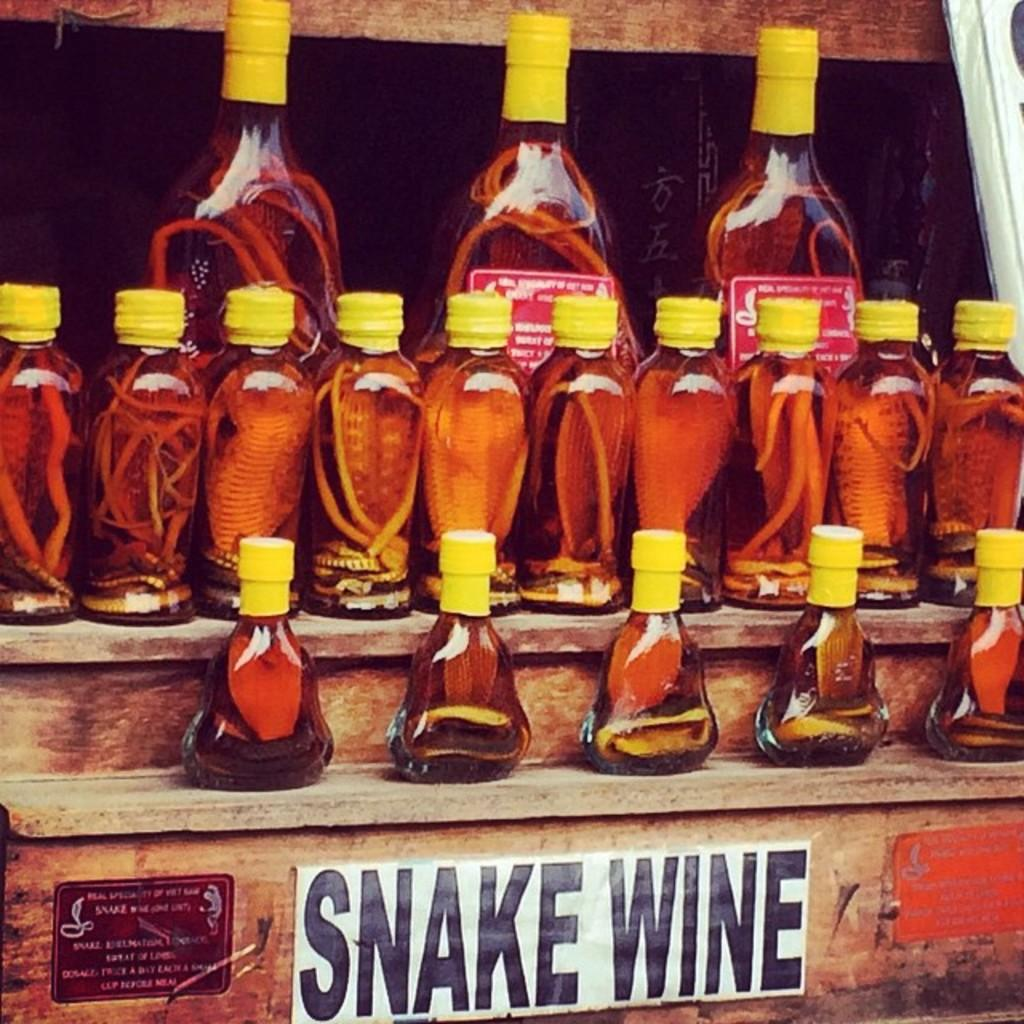<image>
Describe the image concisely. Several bottles are on a wood shelf, which is labelled Snake Wine. 